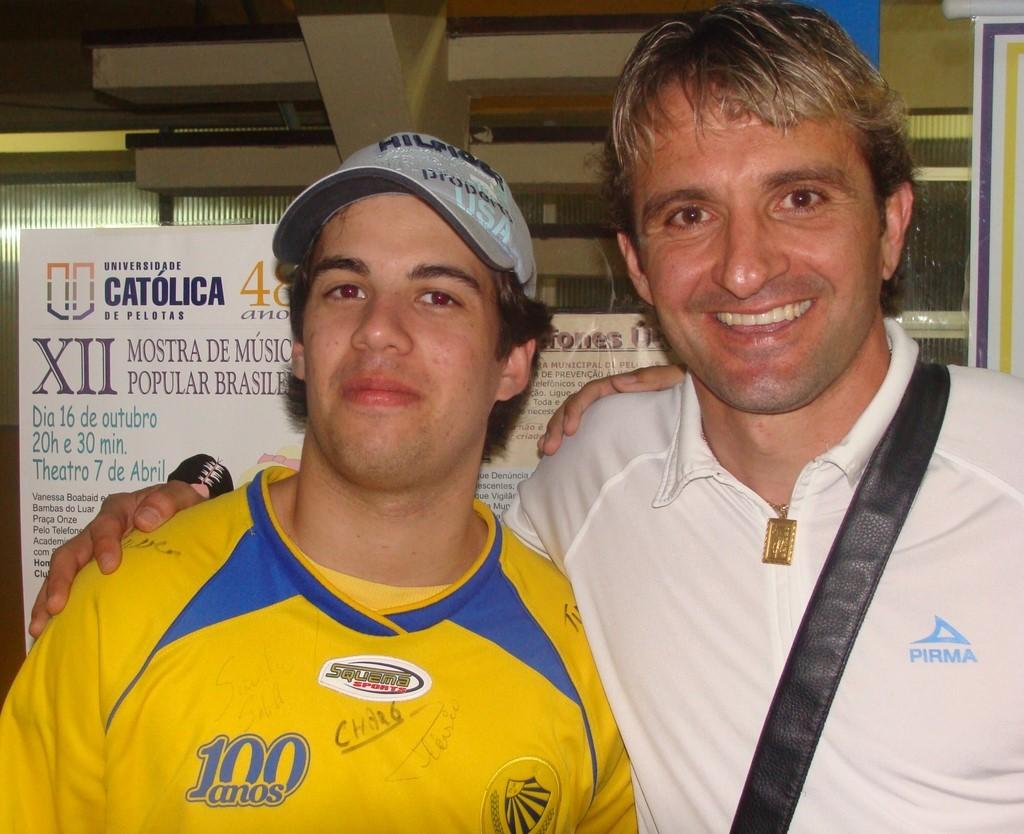<image>
Give a short and clear explanation of the subsequent image. 2 men are smiling for a picture, with the man in yellow wearing a hat that says USA 